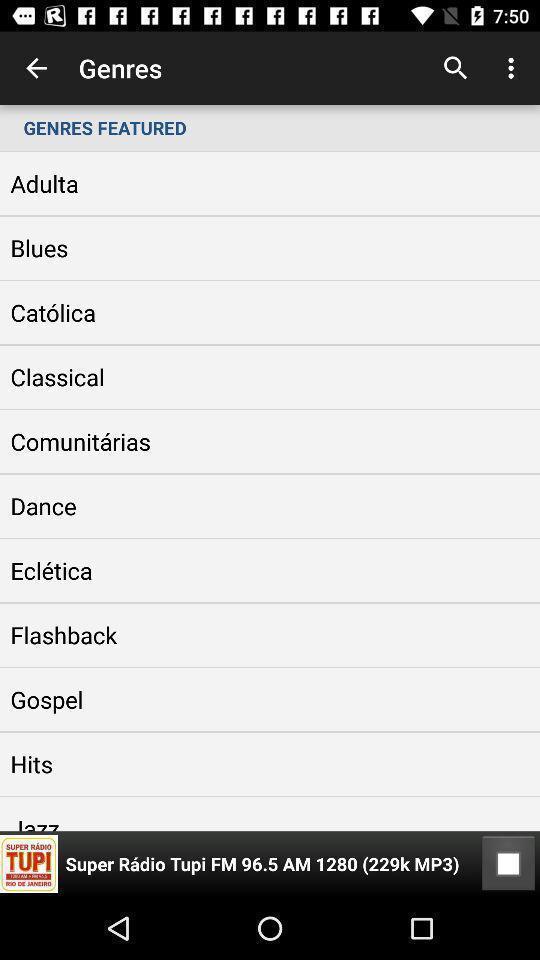What is the overall content of this screenshot? Screen displaying the list of genres. 